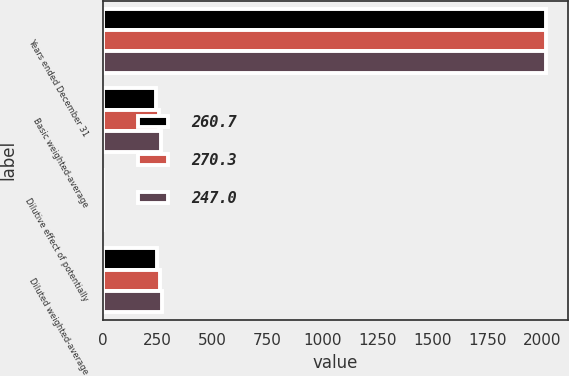Convert chart. <chart><loc_0><loc_0><loc_500><loc_500><stacked_bar_chart><ecel><fcel>Years ended December 31<fcel>Basic weighted-average<fcel>Dilutive effect of potentially<fcel>Diluted weighted-average<nl><fcel>260.7<fcel>2018<fcel>245.2<fcel>1.8<fcel>247<nl><fcel>270.3<fcel>2017<fcel>258.5<fcel>2.2<fcel>260.7<nl><fcel>247<fcel>2016<fcel>268.1<fcel>2.2<fcel>270.3<nl></chart> 